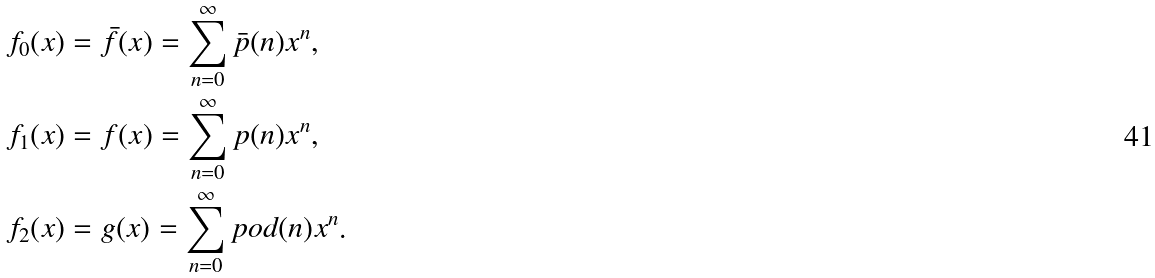<formula> <loc_0><loc_0><loc_500><loc_500>f _ { 0 } ( x ) & = \bar { f } ( x ) = \sum _ { n = 0 } ^ { \infty } \bar { p } ( n ) x ^ { n } , \\ f _ { 1 } ( x ) & = f ( x ) = \sum _ { n = 0 } ^ { \infty } p ( n ) x ^ { n } , \\ f _ { 2 } ( x ) & = g ( x ) = \sum _ { n = 0 } ^ { \infty } p o d ( n ) x ^ { n } .</formula> 